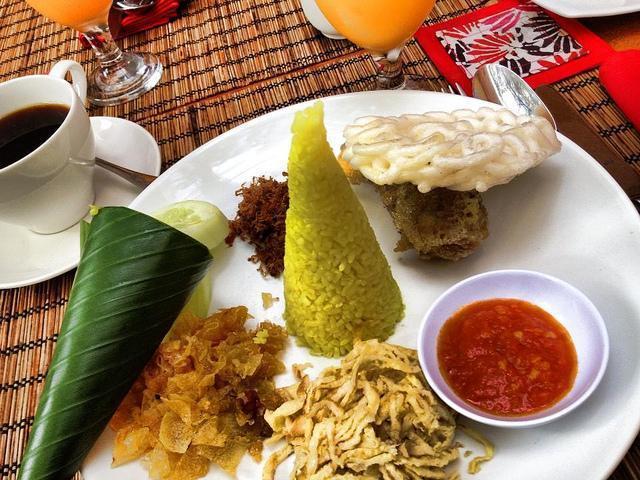How many wine glasses can be seen?
Give a very brief answer. 2. How many women on the bill board are touching their head?
Give a very brief answer. 0. 